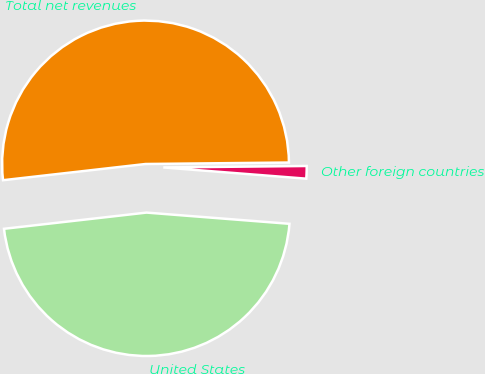<chart> <loc_0><loc_0><loc_500><loc_500><pie_chart><fcel>United States<fcel>Other foreign countries<fcel>Total net revenues<nl><fcel>46.95%<fcel>1.41%<fcel>51.64%<nl></chart> 